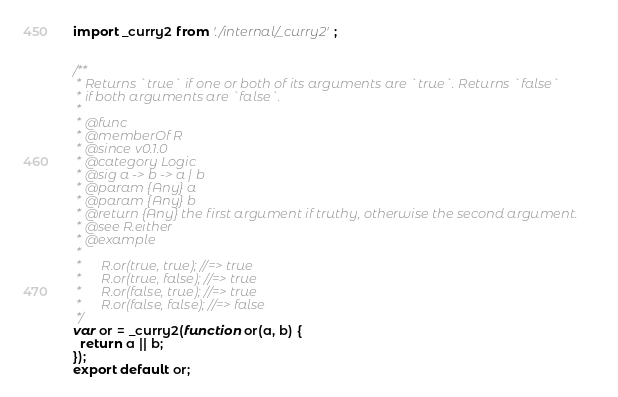Convert code to text. <code><loc_0><loc_0><loc_500><loc_500><_JavaScript_>import _curry2 from './internal/_curry2';


/**
 * Returns `true` if one or both of its arguments are `true`. Returns `false`
 * if both arguments are `false`.
 *
 * @func
 * @memberOf R
 * @since v0.1.0
 * @category Logic
 * @sig a -> b -> a | b
 * @param {Any} a
 * @param {Any} b
 * @return {Any} the first argument if truthy, otherwise the second argument.
 * @see R.either
 * @example
 *
 *      R.or(true, true); //=> true
 *      R.or(true, false); //=> true
 *      R.or(false, true); //=> true
 *      R.or(false, false); //=> false
 */
var or = _curry2(function or(a, b) {
  return a || b;
});
export default or;
</code> 